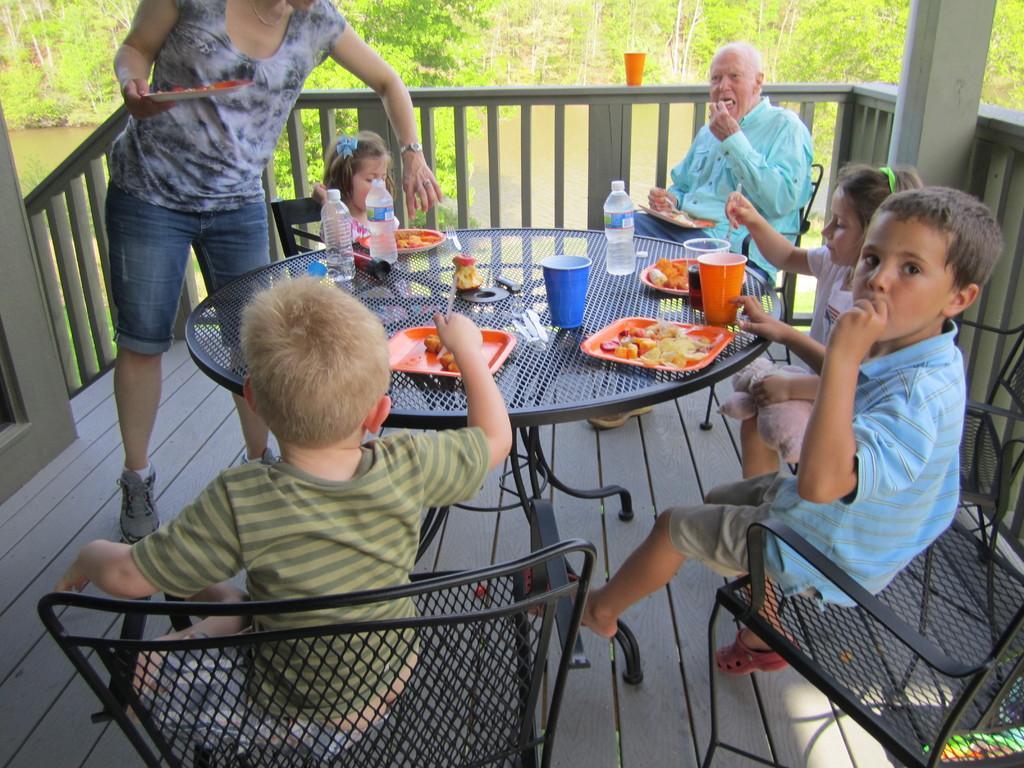Describe this image in one or two sentences. This picture describes about group of people, few are seated on the chair and one person is standing, in front of them we can find couple of glasses, bottles, plates on the table, they are all eating, in the background we can see couple of trees and some water. 